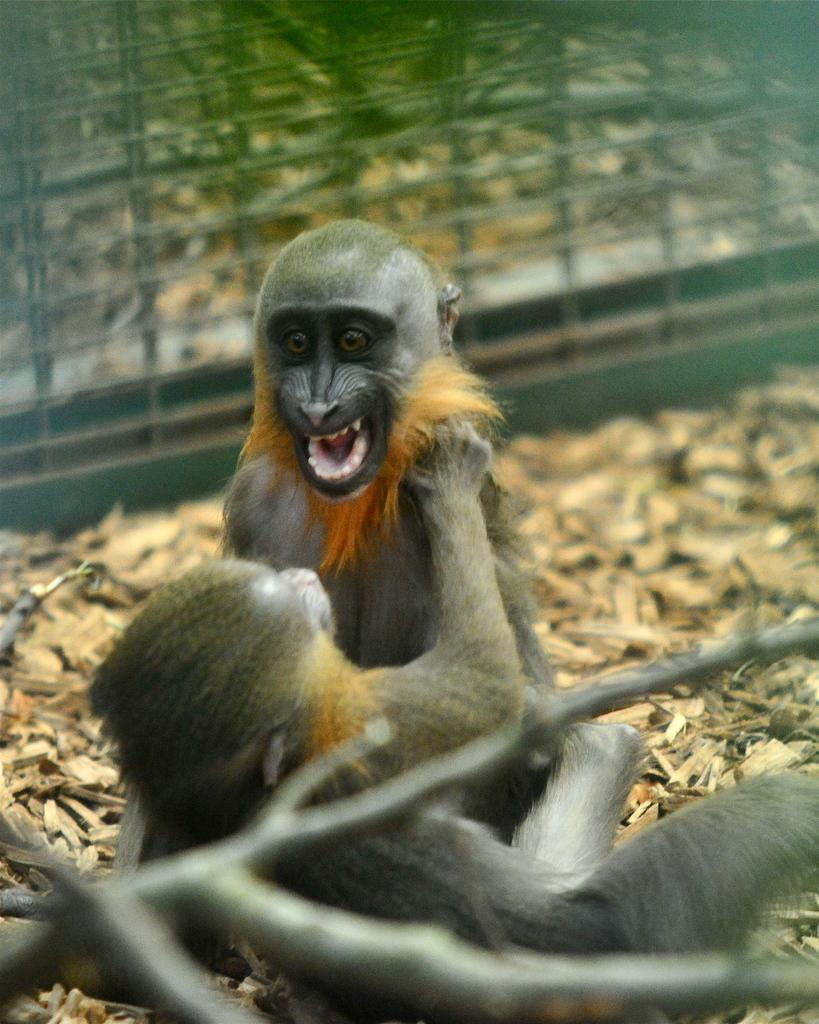What type of animals are in the image? There are monkeys in the image. What can be seen in the background of the image? There is a fence in the background of the image. What type of store can be seen in the image? There is no store present in the image; it features monkeys and a fence in the background. Is there a crook trying to break the lock in the image? There is no crook or lock present in the image. 